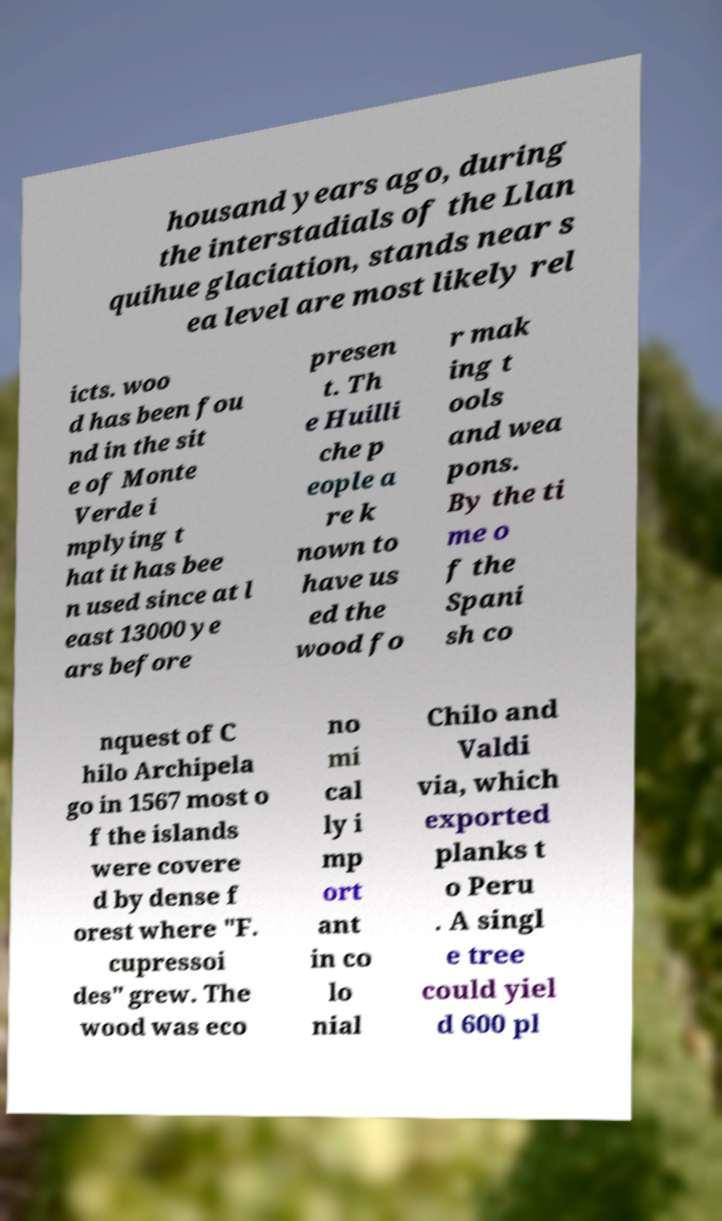Please read and relay the text visible in this image. What does it say? housand years ago, during the interstadials of the Llan quihue glaciation, stands near s ea level are most likely rel icts. woo d has been fou nd in the sit e of Monte Verde i mplying t hat it has bee n used since at l east 13000 ye ars before presen t. Th e Huilli che p eople a re k nown to have us ed the wood fo r mak ing t ools and wea pons. By the ti me o f the Spani sh co nquest of C hilo Archipela go in 1567 most o f the islands were covere d by dense f orest where "F. cupressoi des" grew. The wood was eco no mi cal ly i mp ort ant in co lo nial Chilo and Valdi via, which exported planks t o Peru . A singl e tree could yiel d 600 pl 